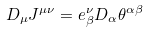<formula> <loc_0><loc_0><loc_500><loc_500>D _ { \mu } J ^ { \mu \nu } = e ^ { \nu } _ { \beta } D _ { \alpha } \theta ^ { \alpha \beta }</formula> 